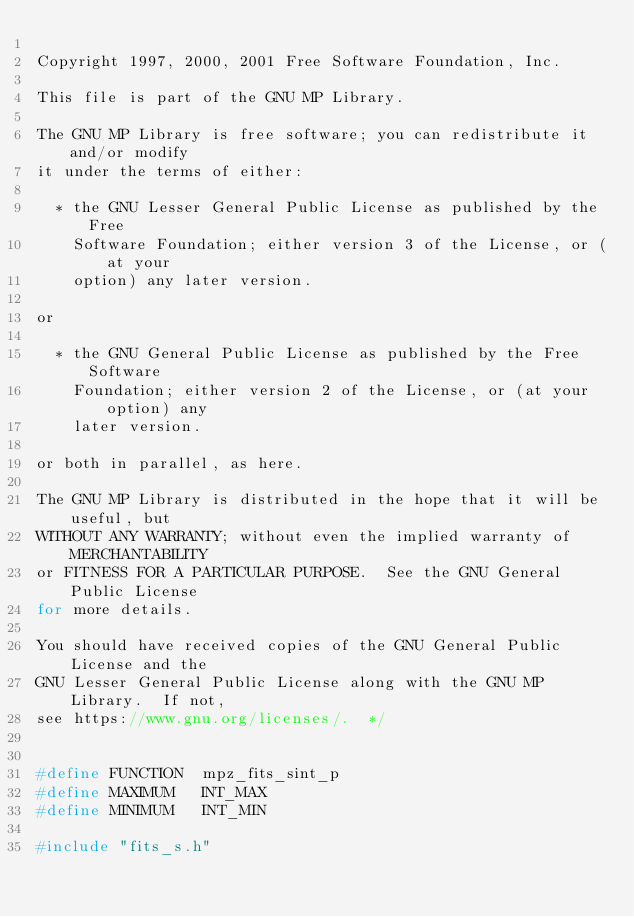Convert code to text. <code><loc_0><loc_0><loc_500><loc_500><_C_>
Copyright 1997, 2000, 2001 Free Software Foundation, Inc.

This file is part of the GNU MP Library.

The GNU MP Library is free software; you can redistribute it and/or modify
it under the terms of either:

  * the GNU Lesser General Public License as published by the Free
    Software Foundation; either version 3 of the License, or (at your
    option) any later version.

or

  * the GNU General Public License as published by the Free Software
    Foundation; either version 2 of the License, or (at your option) any
    later version.

or both in parallel, as here.

The GNU MP Library is distributed in the hope that it will be useful, but
WITHOUT ANY WARRANTY; without even the implied warranty of MERCHANTABILITY
or FITNESS FOR A PARTICULAR PURPOSE.  See the GNU General Public License
for more details.

You should have received copies of the GNU General Public License and the
GNU Lesser General Public License along with the GNU MP Library.  If not,
see https://www.gnu.org/licenses/.  */


#define FUNCTION  mpz_fits_sint_p
#define MAXIMUM   INT_MAX
#define MINIMUM   INT_MIN

#include "fits_s.h"
</code> 